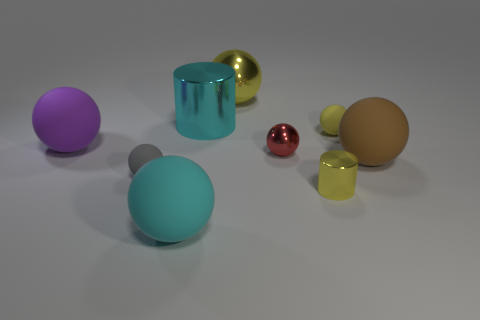What shape is the matte thing that is the same color as the big metallic cylinder?
Ensure brevity in your answer.  Sphere. How many brown matte things are there?
Provide a short and direct response. 1. How many balls are either matte objects or green shiny things?
Your answer should be very brief. 5. The metal cylinder that is the same size as the brown ball is what color?
Ensure brevity in your answer.  Cyan. What number of big things are both left of the big yellow object and on the right side of the large cyan matte object?
Make the answer very short. 1. What is the large yellow ball made of?
Your response must be concise. Metal. What number of things are either big yellow shiny things or yellow spheres?
Your answer should be compact. 2. Is the size of the cyan object that is behind the cyan rubber ball the same as the yellow thing that is to the left of the tiny metallic cylinder?
Your response must be concise. Yes. What number of other objects are the same size as the cyan matte ball?
Keep it short and to the point. 4. How many things are matte balls in front of the purple rubber ball or tiny rubber spheres that are right of the large cyan sphere?
Offer a terse response. 4. 